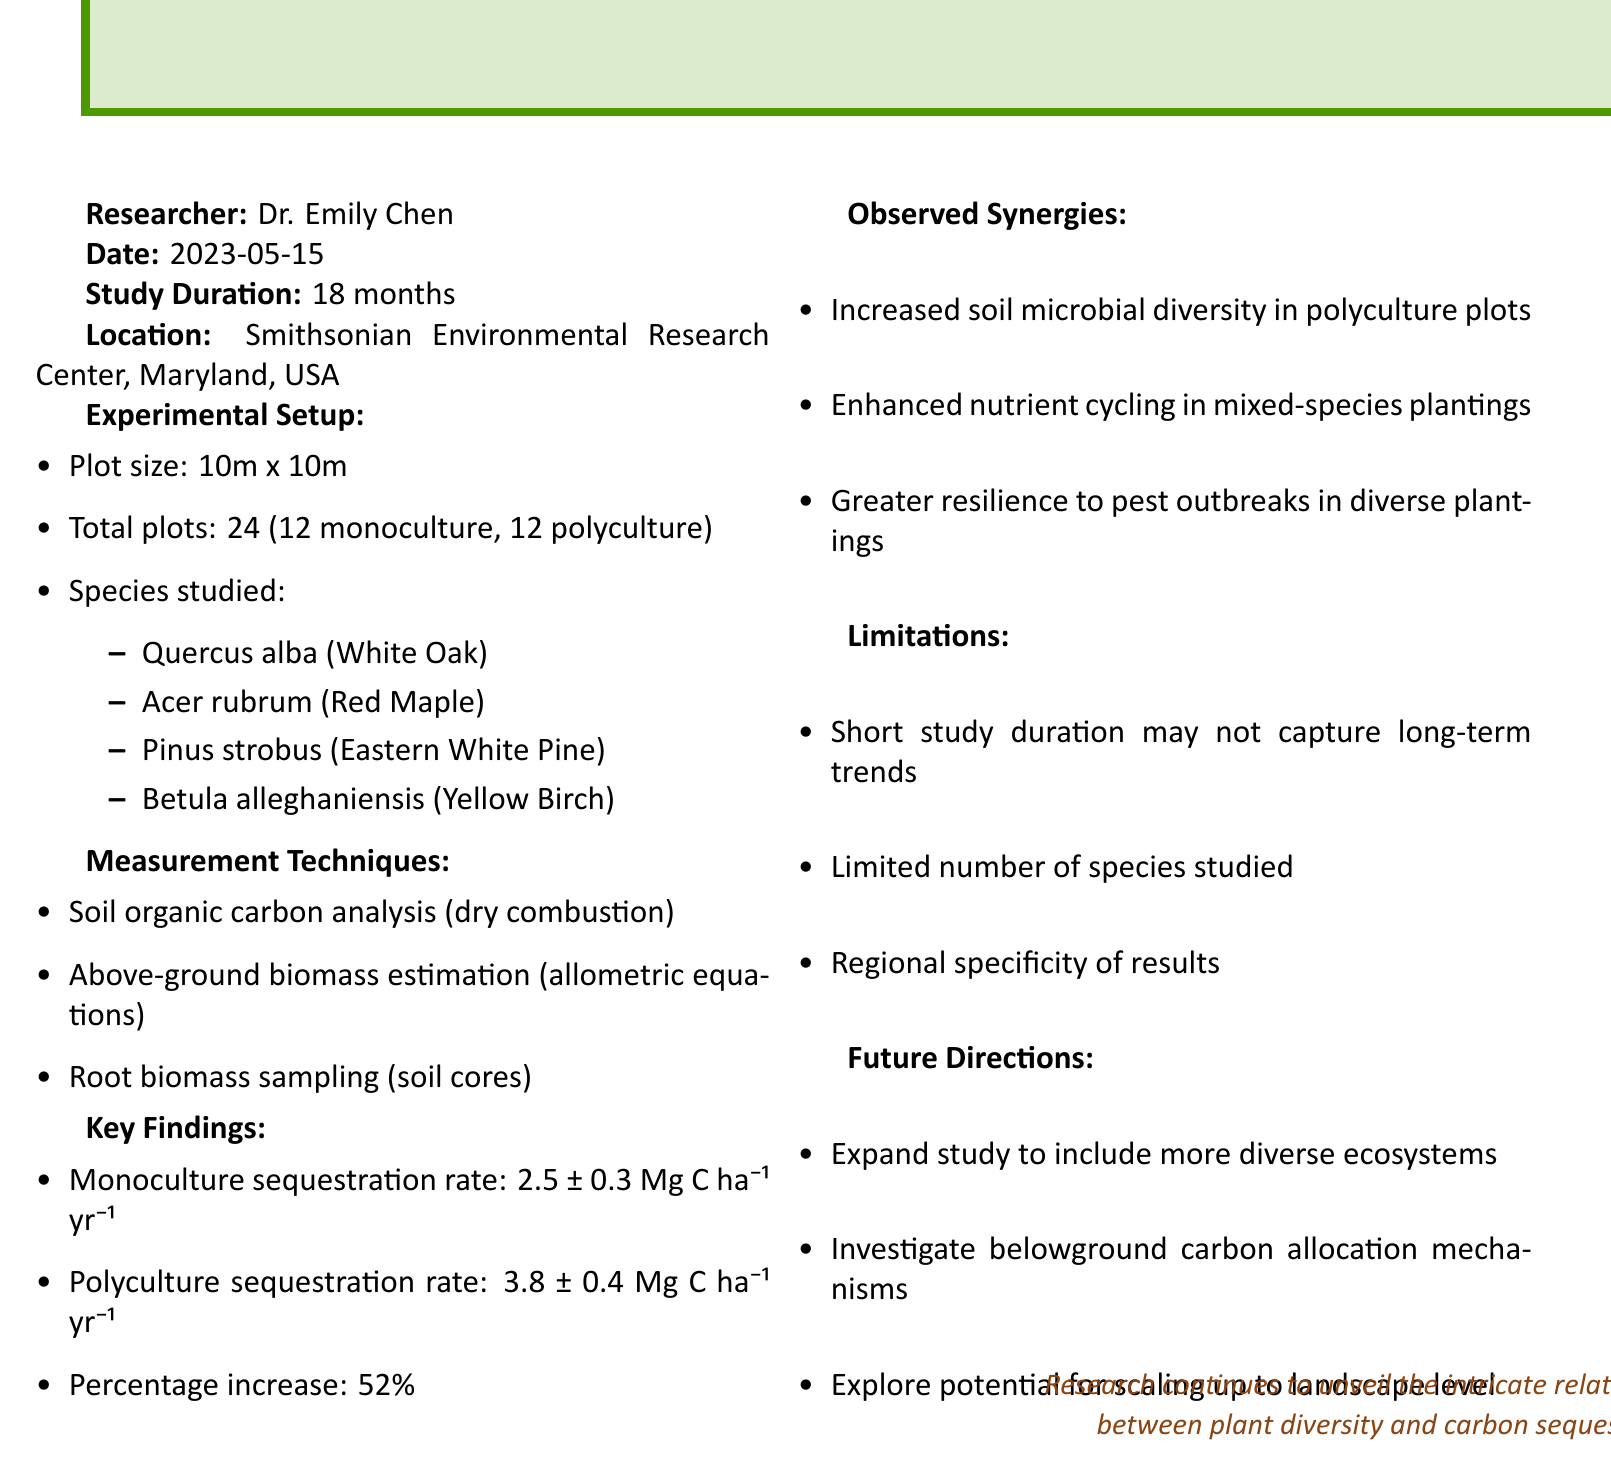What is the title of the study? The title is the main heading of the document, which provides a summary of the study's focus on carbon sequestration rates.
Answer: Lab Notes: Comparative Study of Carbon Sequestration Rates in Monoculture vs. Polyculture Plantings Who is the researcher of the study? The researcher is mentioned early in the document, highlighting the person responsible for conducting the study.
Answer: Dr. Emily Chen What is the study duration? The duration provides information on how long the study was conducted, which is crucial for understanding the results.
Answer: 18 months What is the monoculture sequestration rate? The monoculture sequestration rate is a key finding of the study and indicates the carbon sequestration efficiency of monoculture plantings.
Answer: 2.5 ± 0.3 Mg C ha⁻¹ yr⁻¹ What is the percentage increase in carbon sequestration from monoculture to polyculture? The percentage increase is calculated based on the difference between the two sequestration rates, providing insight into the effectiveness of polyculture.
Answer: 52% What synergies were observed in polyculture plots? The document lists several benefits observed in polyculture plots, showing their ecological advantages.
Answer: Increased soil microbial diversity in polyculture plots What limitations are noted in the study? The limitations give context to the findings and caution against overgeneralization of the results.
Answer: Short study duration may not capture long-term trends What future direction is suggested for the study? Future directions outline the researcher’s plans for expanding or improving upon the current study, indicating ongoing research interests.
Answer: Expand study to include more diverse ecosystems 